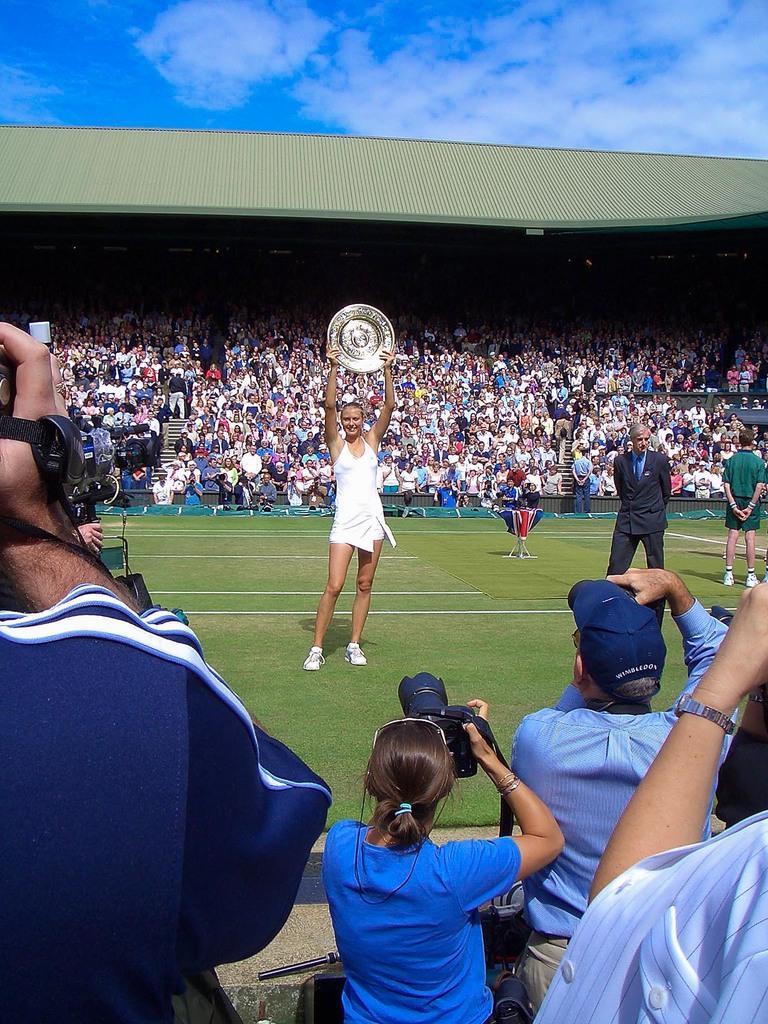Describe this image in one or two sentences. In the foreground of this image, there are few people standing and holding cameras. In the middle, there is a woman standing and holding a shield. On the right, there are two men standing on the grass. In the background, there are people sitting in the stadium. At the top, there is the sky. 